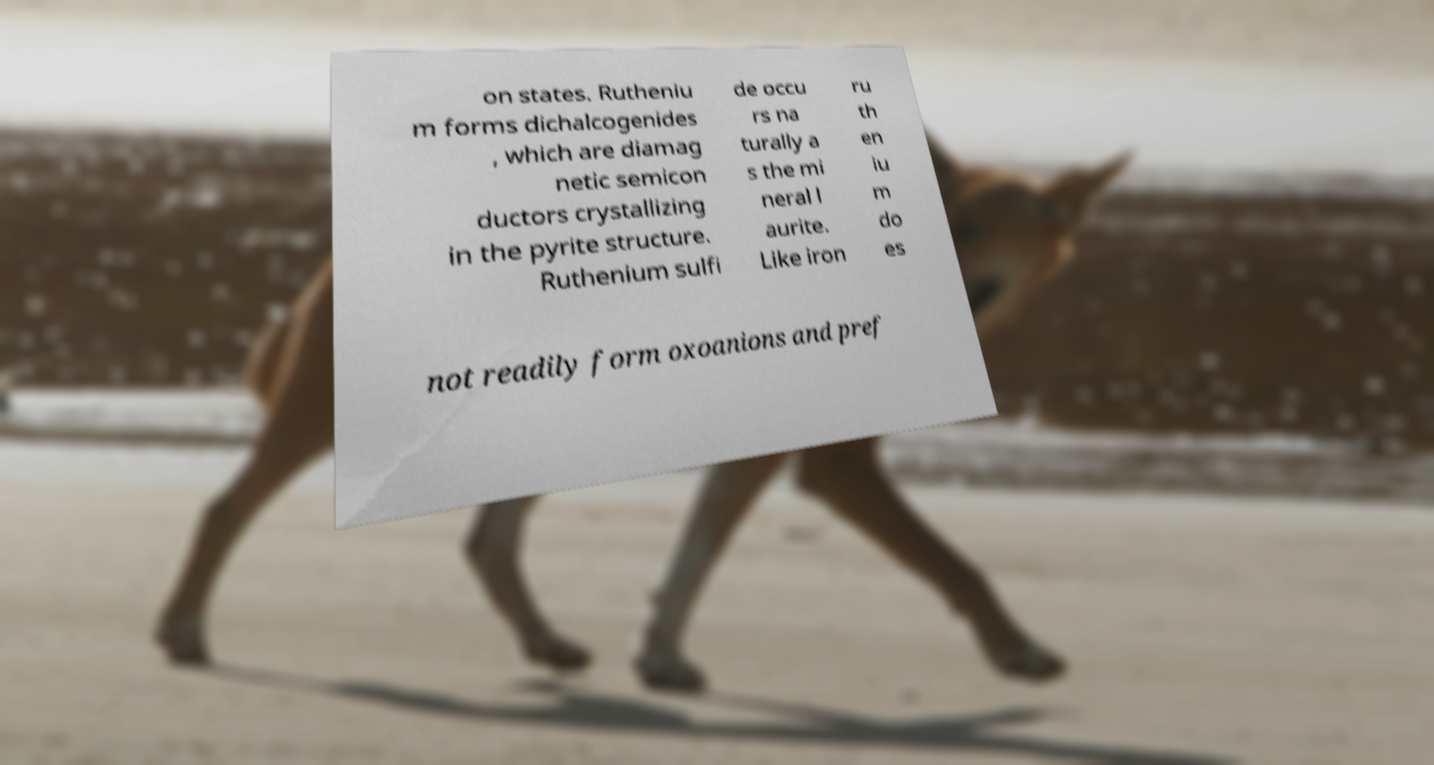For documentation purposes, I need the text within this image transcribed. Could you provide that? on states. Rutheniu m forms dichalcogenides , which are diamag netic semicon ductors crystallizing in the pyrite structure. Ruthenium sulfi de occu rs na turally a s the mi neral l aurite. Like iron ru th en iu m do es not readily form oxoanions and pref 